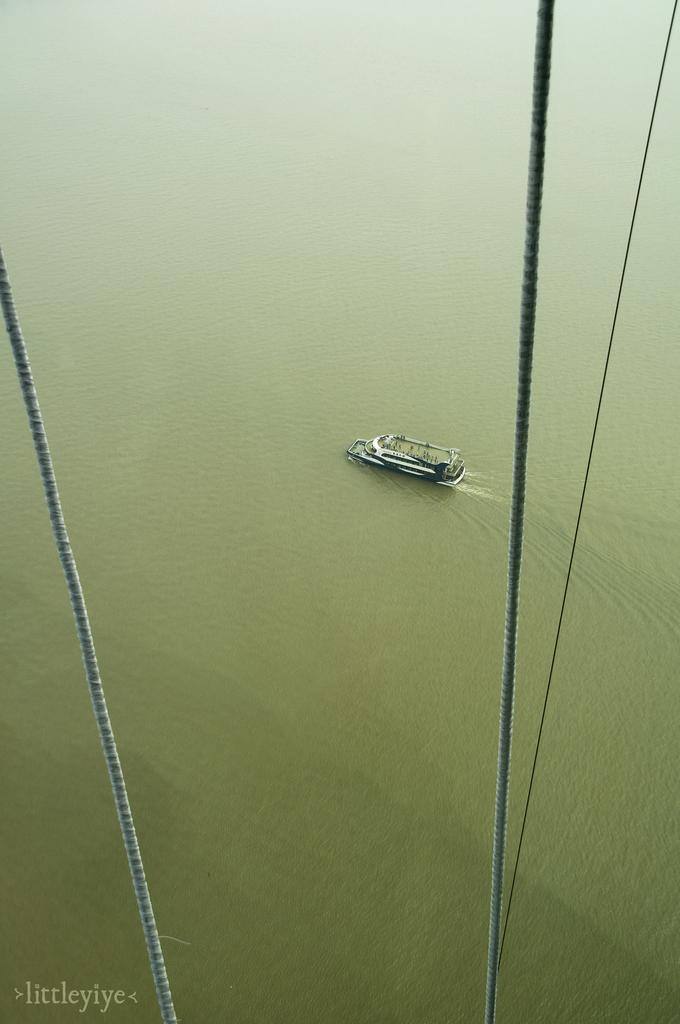What is visible in the image? There is water visible in the image, and there is a boat above the water. Can you describe the boat in the image? Unfortunately, the provided facts do not give any details about the boat's appearance or characteristics. How is the boat positioned in relation to the water? The boat is positioned above the water in the image. How many babies are on the boat in the image? There is no mention of babies in the image, as it only features water and a boat. What type of suggestion can be seen written on the side of the boat? There is no suggestion visible on the boat in the image, as it only features a boat and water. Are there any horses present in the image? There is no mention of horses in the image, as it only features water and a boat. 